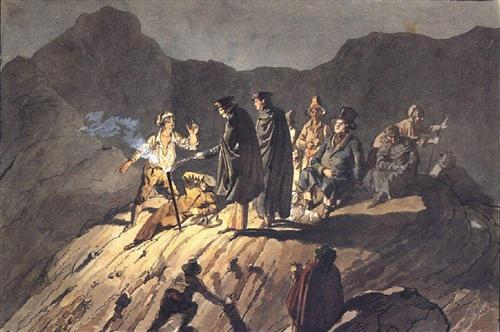Tell me a detailed backstory for one of the figures in the foreground. The figure on the far left, holding a staff with a glowing tip, is a seasoned explorer known as Sir Nathaniel. Born to a family of academics, Nathaniel chose a life of adventure over scholarly pursuits. His staff, rumored to possess mystical properties, was gifted by an enigmatic hermit he encountered during his travels in the East. After years of unearthing ancient relics and uncovering forgotten legends, Nathaniel's journey led him to this desolate cliff. He believes it is the site of a hidden treasure that could unlock secrets from centuries past. However, his presence has also attracted those who seek to claim the treasure for their own, leading to the tense standoff depicted in the scene. What might the glowing staff symbolize in Sir Nathaniel's story? The glowing staff in Sir Nathaniel's story symbolizes knowledge and guidance. It represents his quest for enlightenment and the pursuit of hidden truths. As a beacon in the darkness, the staff guides him through perilous paths and challenges. The light it emits could also signify Nathaniel's influence and leadership, highlighting his role as a seeker of wisdom and protector of ancient secrets. 